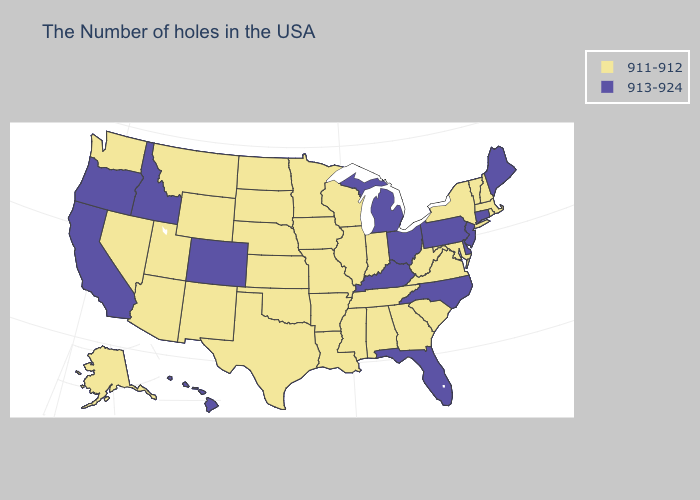What is the lowest value in the South?
Concise answer only. 911-912. Name the states that have a value in the range 911-912?
Give a very brief answer. Massachusetts, Rhode Island, New Hampshire, Vermont, New York, Maryland, Virginia, South Carolina, West Virginia, Georgia, Indiana, Alabama, Tennessee, Wisconsin, Illinois, Mississippi, Louisiana, Missouri, Arkansas, Minnesota, Iowa, Kansas, Nebraska, Oklahoma, Texas, South Dakota, North Dakota, Wyoming, New Mexico, Utah, Montana, Arizona, Nevada, Washington, Alaska. Does West Virginia have the highest value in the South?
Write a very short answer. No. What is the highest value in the USA?
Write a very short answer. 913-924. Which states have the lowest value in the USA?
Write a very short answer. Massachusetts, Rhode Island, New Hampshire, Vermont, New York, Maryland, Virginia, South Carolina, West Virginia, Georgia, Indiana, Alabama, Tennessee, Wisconsin, Illinois, Mississippi, Louisiana, Missouri, Arkansas, Minnesota, Iowa, Kansas, Nebraska, Oklahoma, Texas, South Dakota, North Dakota, Wyoming, New Mexico, Utah, Montana, Arizona, Nevada, Washington, Alaska. Among the states that border Arkansas , which have the lowest value?
Write a very short answer. Tennessee, Mississippi, Louisiana, Missouri, Oklahoma, Texas. Among the states that border Alabama , which have the highest value?
Write a very short answer. Florida. What is the value of North Dakota?
Write a very short answer. 911-912. What is the value of Nebraska?
Answer briefly. 911-912. Does Rhode Island have the lowest value in the USA?
Write a very short answer. Yes. How many symbols are there in the legend?
Keep it brief. 2. Name the states that have a value in the range 913-924?
Quick response, please. Maine, Connecticut, New Jersey, Delaware, Pennsylvania, North Carolina, Ohio, Florida, Michigan, Kentucky, Colorado, Idaho, California, Oregon, Hawaii. Name the states that have a value in the range 911-912?
Give a very brief answer. Massachusetts, Rhode Island, New Hampshire, Vermont, New York, Maryland, Virginia, South Carolina, West Virginia, Georgia, Indiana, Alabama, Tennessee, Wisconsin, Illinois, Mississippi, Louisiana, Missouri, Arkansas, Minnesota, Iowa, Kansas, Nebraska, Oklahoma, Texas, South Dakota, North Dakota, Wyoming, New Mexico, Utah, Montana, Arizona, Nevada, Washington, Alaska. What is the lowest value in states that border New Mexico?
Be succinct. 911-912. Among the states that border Nevada , which have the highest value?
Keep it brief. Idaho, California, Oregon. 